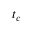<formula> <loc_0><loc_0><loc_500><loc_500>t _ { c }</formula> 